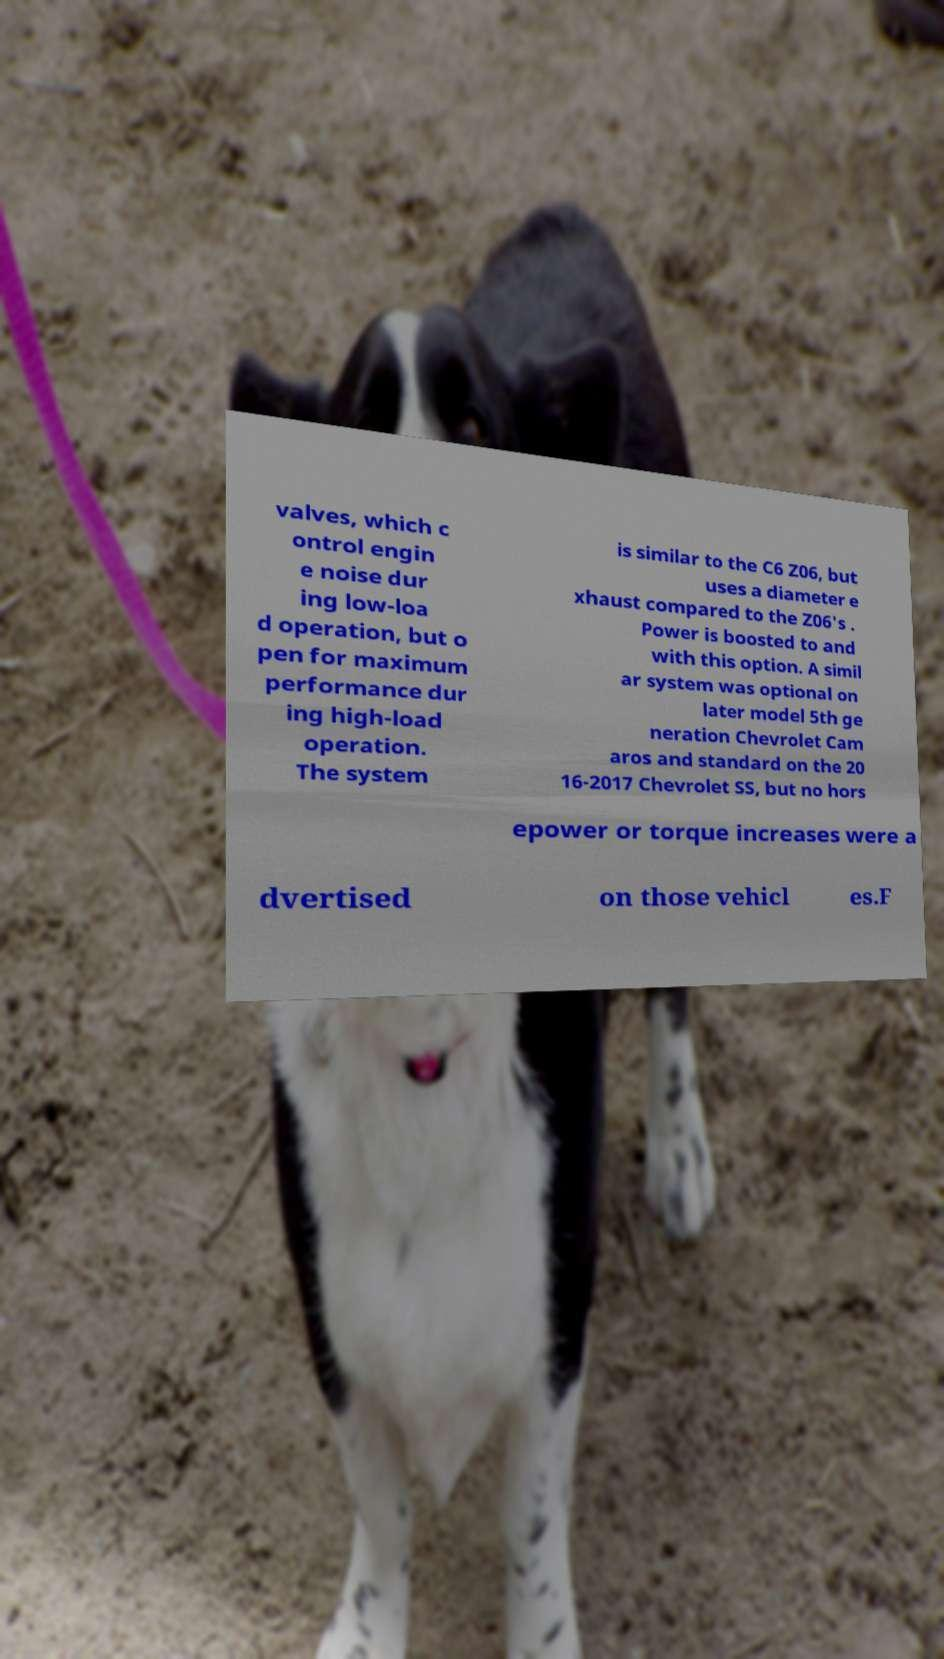What messages or text are displayed in this image? I need them in a readable, typed format. valves, which c ontrol engin e noise dur ing low-loa d operation, but o pen for maximum performance dur ing high-load operation. The system is similar to the C6 Z06, but uses a diameter e xhaust compared to the Z06's . Power is boosted to and with this option. A simil ar system was optional on later model 5th ge neration Chevrolet Cam aros and standard on the 20 16-2017 Chevrolet SS, but no hors epower or torque increases were a dvertised on those vehicl es.F 